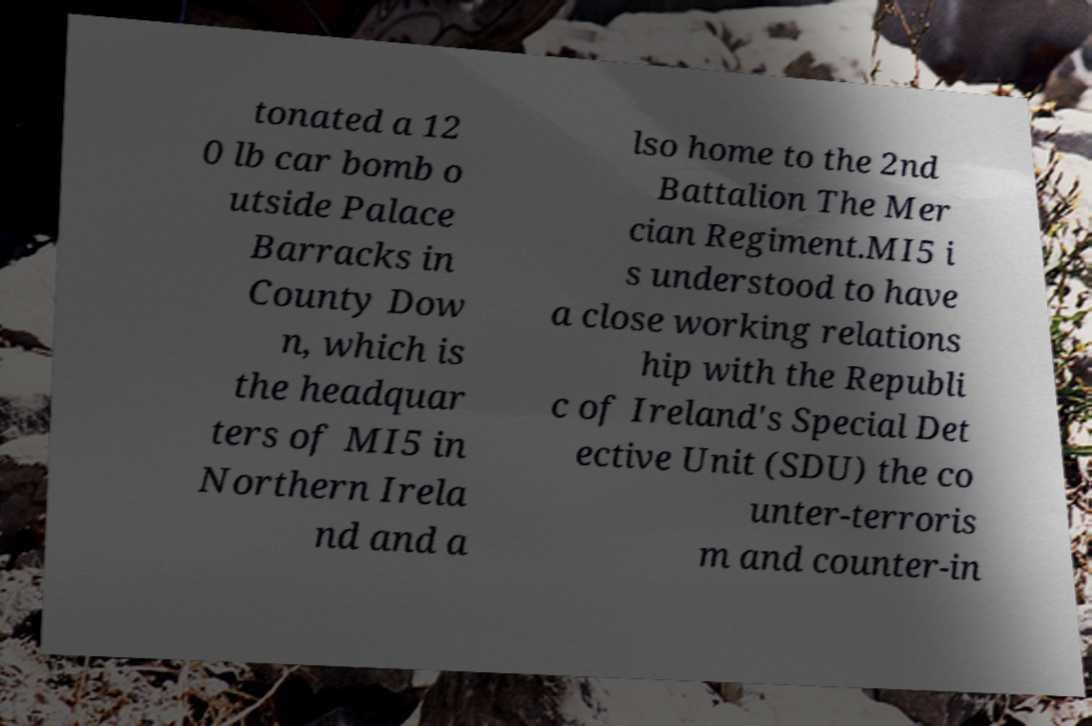What messages or text are displayed in this image? I need them in a readable, typed format. tonated a 12 0 lb car bomb o utside Palace Barracks in County Dow n, which is the headquar ters of MI5 in Northern Irela nd and a lso home to the 2nd Battalion The Mer cian Regiment.MI5 i s understood to have a close working relations hip with the Republi c of Ireland's Special Det ective Unit (SDU) the co unter-terroris m and counter-in 